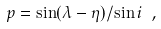Convert formula to latex. <formula><loc_0><loc_0><loc_500><loc_500>p = \sin ( \lambda - \eta ) / \sin i \ ,</formula> 